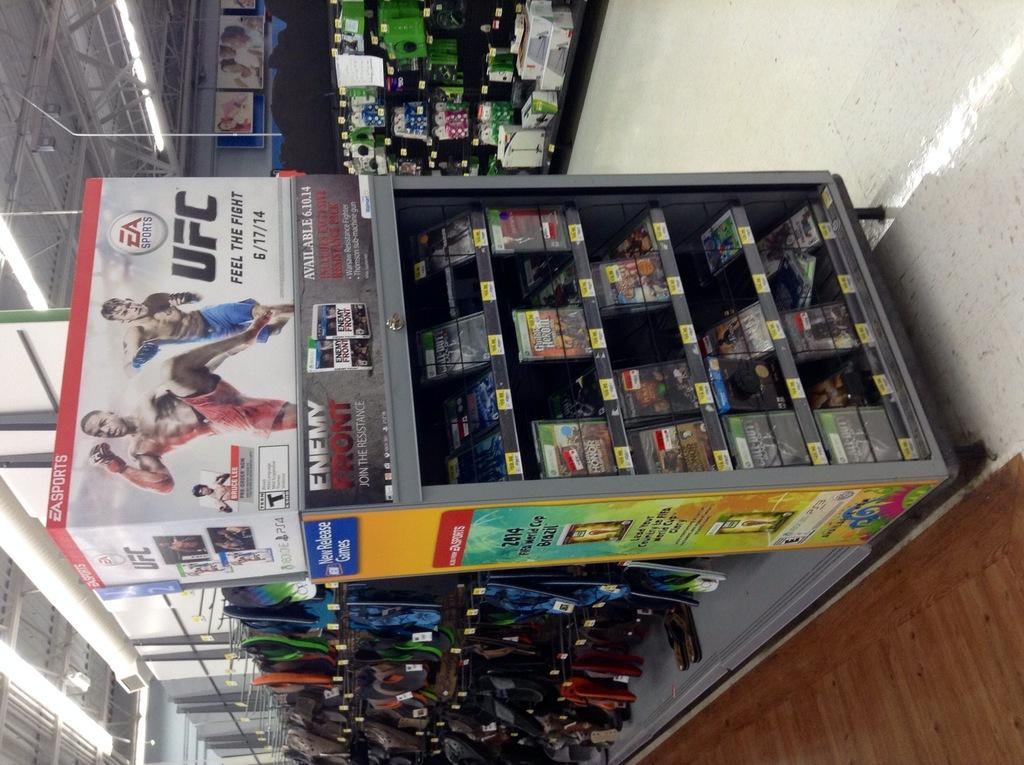What type of establishment is shown in the image? There is a store in the image. How are the objects in the store organized? The objects are placed in racks. What can be seen illuminating the store? There are lights visible in the image. What else is present in the image besides the store and its contents? There are other objects in the left corner of the image. What type of pancake is being sold in the store in the image? There is no pancake visible in the image, nor is there any indication that the store sells pancakes. 